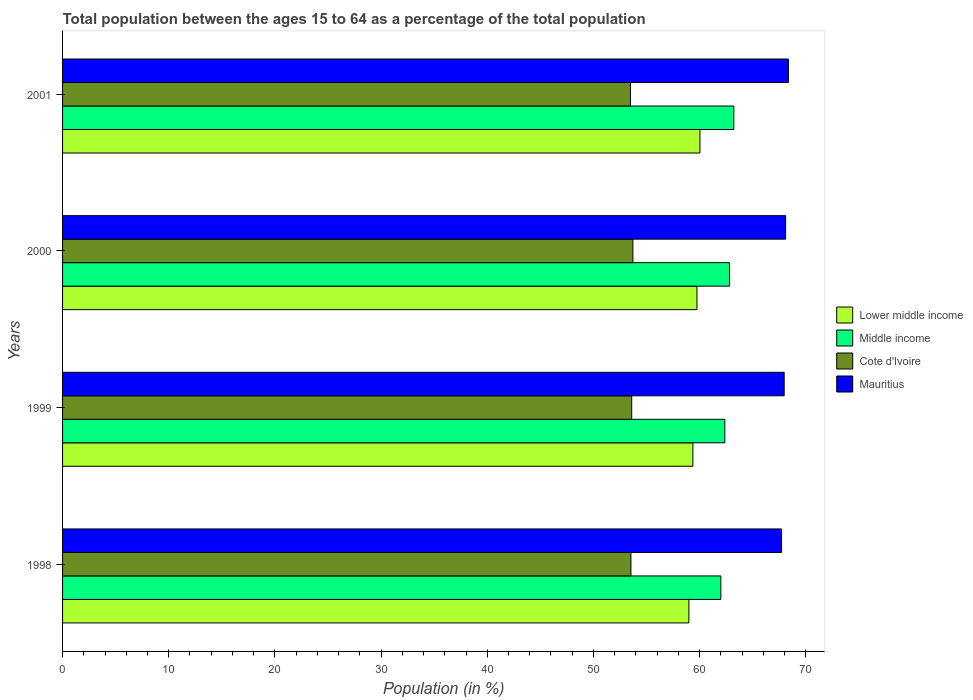Are the number of bars per tick equal to the number of legend labels?
Offer a terse response. Yes. Are the number of bars on each tick of the Y-axis equal?
Make the answer very short. Yes. How many bars are there on the 4th tick from the bottom?
Offer a very short reply. 4. What is the label of the 1st group of bars from the top?
Offer a terse response. 2001. In how many cases, is the number of bars for a given year not equal to the number of legend labels?
Ensure brevity in your answer.  0. What is the percentage of the population ages 15 to 64 in Lower middle income in 2001?
Your answer should be compact. 60.04. Across all years, what is the maximum percentage of the population ages 15 to 64 in Middle income?
Provide a succinct answer. 63.23. Across all years, what is the minimum percentage of the population ages 15 to 64 in Mauritius?
Give a very brief answer. 67.72. In which year was the percentage of the population ages 15 to 64 in Lower middle income maximum?
Your answer should be very brief. 2001. In which year was the percentage of the population ages 15 to 64 in Lower middle income minimum?
Ensure brevity in your answer.  1998. What is the total percentage of the population ages 15 to 64 in Mauritius in the graph?
Provide a short and direct response. 272.15. What is the difference between the percentage of the population ages 15 to 64 in Lower middle income in 1998 and that in 2000?
Give a very brief answer. -0.76. What is the difference between the percentage of the population ages 15 to 64 in Lower middle income in 2000 and the percentage of the population ages 15 to 64 in Cote d'Ivoire in 1999?
Offer a terse response. 6.15. What is the average percentage of the population ages 15 to 64 in Mauritius per year?
Make the answer very short. 68.04. In the year 2000, what is the difference between the percentage of the population ages 15 to 64 in Cote d'Ivoire and percentage of the population ages 15 to 64 in Lower middle income?
Your answer should be very brief. -6.03. What is the ratio of the percentage of the population ages 15 to 64 in Cote d'Ivoire in 1998 to that in 2000?
Your answer should be compact. 1. Is the percentage of the population ages 15 to 64 in Middle income in 2000 less than that in 2001?
Your response must be concise. Yes. Is the difference between the percentage of the population ages 15 to 64 in Cote d'Ivoire in 1999 and 2001 greater than the difference between the percentage of the population ages 15 to 64 in Lower middle income in 1999 and 2001?
Provide a short and direct response. Yes. What is the difference between the highest and the second highest percentage of the population ages 15 to 64 in Cote d'Ivoire?
Offer a terse response. 0.11. What is the difference between the highest and the lowest percentage of the population ages 15 to 64 in Lower middle income?
Offer a very short reply. 1.04. In how many years, is the percentage of the population ages 15 to 64 in Mauritius greater than the average percentage of the population ages 15 to 64 in Mauritius taken over all years?
Give a very brief answer. 2. Is the sum of the percentage of the population ages 15 to 64 in Mauritius in 1998 and 2001 greater than the maximum percentage of the population ages 15 to 64 in Middle income across all years?
Give a very brief answer. Yes. Is it the case that in every year, the sum of the percentage of the population ages 15 to 64 in Middle income and percentage of the population ages 15 to 64 in Mauritius is greater than the sum of percentage of the population ages 15 to 64 in Cote d'Ivoire and percentage of the population ages 15 to 64 in Lower middle income?
Offer a very short reply. Yes. What does the 4th bar from the top in 2000 represents?
Ensure brevity in your answer.  Lower middle income. What does the 3rd bar from the bottom in 1998 represents?
Ensure brevity in your answer.  Cote d'Ivoire. How many bars are there?
Give a very brief answer. 16. Are the values on the major ticks of X-axis written in scientific E-notation?
Your answer should be very brief. No. How many legend labels are there?
Provide a short and direct response. 4. What is the title of the graph?
Offer a very short reply. Total population between the ages 15 to 64 as a percentage of the total population. What is the label or title of the Y-axis?
Your response must be concise. Years. What is the Population (in %) in Lower middle income in 1998?
Make the answer very short. 58.99. What is the Population (in %) of Middle income in 1998?
Make the answer very short. 62. What is the Population (in %) in Cote d'Ivoire in 1998?
Offer a very short reply. 53.53. What is the Population (in %) of Mauritius in 1998?
Your answer should be very brief. 67.72. What is the Population (in %) in Lower middle income in 1999?
Your answer should be very brief. 59.37. What is the Population (in %) of Middle income in 1999?
Provide a short and direct response. 62.38. What is the Population (in %) of Cote d'Ivoire in 1999?
Ensure brevity in your answer.  53.61. What is the Population (in %) in Mauritius in 1999?
Your response must be concise. 67.97. What is the Population (in %) in Lower middle income in 2000?
Provide a short and direct response. 59.75. What is the Population (in %) in Middle income in 2000?
Make the answer very short. 62.82. What is the Population (in %) in Cote d'Ivoire in 2000?
Make the answer very short. 53.72. What is the Population (in %) of Mauritius in 2000?
Keep it short and to the point. 68.1. What is the Population (in %) of Lower middle income in 2001?
Your answer should be compact. 60.04. What is the Population (in %) of Middle income in 2001?
Make the answer very short. 63.23. What is the Population (in %) in Cote d'Ivoire in 2001?
Offer a very short reply. 53.49. What is the Population (in %) in Mauritius in 2001?
Provide a succinct answer. 68.37. Across all years, what is the maximum Population (in %) in Lower middle income?
Provide a succinct answer. 60.04. Across all years, what is the maximum Population (in %) in Middle income?
Ensure brevity in your answer.  63.23. Across all years, what is the maximum Population (in %) of Cote d'Ivoire?
Make the answer very short. 53.72. Across all years, what is the maximum Population (in %) of Mauritius?
Your response must be concise. 68.37. Across all years, what is the minimum Population (in %) of Lower middle income?
Ensure brevity in your answer.  58.99. Across all years, what is the minimum Population (in %) of Middle income?
Offer a terse response. 62. Across all years, what is the minimum Population (in %) of Cote d'Ivoire?
Provide a succinct answer. 53.49. Across all years, what is the minimum Population (in %) in Mauritius?
Keep it short and to the point. 67.72. What is the total Population (in %) in Lower middle income in the graph?
Ensure brevity in your answer.  238.15. What is the total Population (in %) of Middle income in the graph?
Ensure brevity in your answer.  250.43. What is the total Population (in %) of Cote d'Ivoire in the graph?
Your answer should be compact. 214.35. What is the total Population (in %) in Mauritius in the graph?
Keep it short and to the point. 272.15. What is the difference between the Population (in %) of Lower middle income in 1998 and that in 1999?
Your answer should be compact. -0.38. What is the difference between the Population (in %) in Middle income in 1998 and that in 1999?
Give a very brief answer. -0.38. What is the difference between the Population (in %) of Cote d'Ivoire in 1998 and that in 1999?
Give a very brief answer. -0.07. What is the difference between the Population (in %) of Mauritius in 1998 and that in 1999?
Your answer should be very brief. -0.25. What is the difference between the Population (in %) in Lower middle income in 1998 and that in 2000?
Your answer should be very brief. -0.76. What is the difference between the Population (in %) of Middle income in 1998 and that in 2000?
Provide a short and direct response. -0.82. What is the difference between the Population (in %) of Cote d'Ivoire in 1998 and that in 2000?
Provide a succinct answer. -0.18. What is the difference between the Population (in %) of Mauritius in 1998 and that in 2000?
Offer a very short reply. -0.38. What is the difference between the Population (in %) of Lower middle income in 1998 and that in 2001?
Make the answer very short. -1.04. What is the difference between the Population (in %) of Middle income in 1998 and that in 2001?
Your answer should be compact. -1.22. What is the difference between the Population (in %) of Cote d'Ivoire in 1998 and that in 2001?
Your answer should be compact. 0.05. What is the difference between the Population (in %) of Mauritius in 1998 and that in 2001?
Your answer should be compact. -0.65. What is the difference between the Population (in %) of Lower middle income in 1999 and that in 2000?
Keep it short and to the point. -0.38. What is the difference between the Population (in %) of Middle income in 1999 and that in 2000?
Make the answer very short. -0.44. What is the difference between the Population (in %) of Cote d'Ivoire in 1999 and that in 2000?
Give a very brief answer. -0.11. What is the difference between the Population (in %) of Mauritius in 1999 and that in 2000?
Your answer should be compact. -0.14. What is the difference between the Population (in %) in Lower middle income in 1999 and that in 2001?
Provide a short and direct response. -0.67. What is the difference between the Population (in %) of Middle income in 1999 and that in 2001?
Ensure brevity in your answer.  -0.85. What is the difference between the Population (in %) in Cote d'Ivoire in 1999 and that in 2001?
Your answer should be very brief. 0.12. What is the difference between the Population (in %) of Mauritius in 1999 and that in 2001?
Make the answer very short. -0.4. What is the difference between the Population (in %) in Lower middle income in 2000 and that in 2001?
Your response must be concise. -0.28. What is the difference between the Population (in %) in Middle income in 2000 and that in 2001?
Offer a very short reply. -0.4. What is the difference between the Population (in %) in Cote d'Ivoire in 2000 and that in 2001?
Ensure brevity in your answer.  0.23. What is the difference between the Population (in %) in Mauritius in 2000 and that in 2001?
Give a very brief answer. -0.26. What is the difference between the Population (in %) in Lower middle income in 1998 and the Population (in %) in Middle income in 1999?
Give a very brief answer. -3.39. What is the difference between the Population (in %) of Lower middle income in 1998 and the Population (in %) of Cote d'Ivoire in 1999?
Offer a terse response. 5.38. What is the difference between the Population (in %) of Lower middle income in 1998 and the Population (in %) of Mauritius in 1999?
Your answer should be compact. -8.98. What is the difference between the Population (in %) of Middle income in 1998 and the Population (in %) of Cote d'Ivoire in 1999?
Your answer should be compact. 8.4. What is the difference between the Population (in %) in Middle income in 1998 and the Population (in %) in Mauritius in 1999?
Keep it short and to the point. -5.96. What is the difference between the Population (in %) in Cote d'Ivoire in 1998 and the Population (in %) in Mauritius in 1999?
Make the answer very short. -14.43. What is the difference between the Population (in %) of Lower middle income in 1998 and the Population (in %) of Middle income in 2000?
Your response must be concise. -3.83. What is the difference between the Population (in %) of Lower middle income in 1998 and the Population (in %) of Cote d'Ivoire in 2000?
Your answer should be very brief. 5.27. What is the difference between the Population (in %) in Lower middle income in 1998 and the Population (in %) in Mauritius in 2000?
Your answer should be compact. -9.11. What is the difference between the Population (in %) of Middle income in 1998 and the Population (in %) of Cote d'Ivoire in 2000?
Your response must be concise. 8.28. What is the difference between the Population (in %) in Middle income in 1998 and the Population (in %) in Mauritius in 2000?
Make the answer very short. -6.1. What is the difference between the Population (in %) of Cote d'Ivoire in 1998 and the Population (in %) of Mauritius in 2000?
Your answer should be very brief. -14.57. What is the difference between the Population (in %) of Lower middle income in 1998 and the Population (in %) of Middle income in 2001?
Offer a very short reply. -4.23. What is the difference between the Population (in %) in Lower middle income in 1998 and the Population (in %) in Cote d'Ivoire in 2001?
Your answer should be compact. 5.5. What is the difference between the Population (in %) of Lower middle income in 1998 and the Population (in %) of Mauritius in 2001?
Your answer should be very brief. -9.37. What is the difference between the Population (in %) in Middle income in 1998 and the Population (in %) in Cote d'Ivoire in 2001?
Offer a terse response. 8.51. What is the difference between the Population (in %) in Middle income in 1998 and the Population (in %) in Mauritius in 2001?
Keep it short and to the point. -6.36. What is the difference between the Population (in %) of Cote d'Ivoire in 1998 and the Population (in %) of Mauritius in 2001?
Offer a terse response. -14.83. What is the difference between the Population (in %) in Lower middle income in 1999 and the Population (in %) in Middle income in 2000?
Your answer should be compact. -3.45. What is the difference between the Population (in %) of Lower middle income in 1999 and the Population (in %) of Cote d'Ivoire in 2000?
Offer a terse response. 5.65. What is the difference between the Population (in %) of Lower middle income in 1999 and the Population (in %) of Mauritius in 2000?
Offer a very short reply. -8.73. What is the difference between the Population (in %) of Middle income in 1999 and the Population (in %) of Cote d'Ivoire in 2000?
Offer a very short reply. 8.66. What is the difference between the Population (in %) in Middle income in 1999 and the Population (in %) in Mauritius in 2000?
Provide a short and direct response. -5.72. What is the difference between the Population (in %) in Cote d'Ivoire in 1999 and the Population (in %) in Mauritius in 2000?
Keep it short and to the point. -14.5. What is the difference between the Population (in %) of Lower middle income in 1999 and the Population (in %) of Middle income in 2001?
Your answer should be compact. -3.86. What is the difference between the Population (in %) in Lower middle income in 1999 and the Population (in %) in Cote d'Ivoire in 2001?
Your answer should be very brief. 5.88. What is the difference between the Population (in %) in Lower middle income in 1999 and the Population (in %) in Mauritius in 2001?
Make the answer very short. -9. What is the difference between the Population (in %) of Middle income in 1999 and the Population (in %) of Cote d'Ivoire in 2001?
Offer a terse response. 8.89. What is the difference between the Population (in %) of Middle income in 1999 and the Population (in %) of Mauritius in 2001?
Your answer should be very brief. -5.99. What is the difference between the Population (in %) of Cote d'Ivoire in 1999 and the Population (in %) of Mauritius in 2001?
Give a very brief answer. -14.76. What is the difference between the Population (in %) of Lower middle income in 2000 and the Population (in %) of Middle income in 2001?
Ensure brevity in your answer.  -3.47. What is the difference between the Population (in %) in Lower middle income in 2000 and the Population (in %) in Cote d'Ivoire in 2001?
Provide a succinct answer. 6.27. What is the difference between the Population (in %) of Lower middle income in 2000 and the Population (in %) of Mauritius in 2001?
Ensure brevity in your answer.  -8.61. What is the difference between the Population (in %) in Middle income in 2000 and the Population (in %) in Cote d'Ivoire in 2001?
Make the answer very short. 9.34. What is the difference between the Population (in %) in Middle income in 2000 and the Population (in %) in Mauritius in 2001?
Offer a very short reply. -5.54. What is the difference between the Population (in %) in Cote d'Ivoire in 2000 and the Population (in %) in Mauritius in 2001?
Offer a very short reply. -14.65. What is the average Population (in %) of Lower middle income per year?
Keep it short and to the point. 59.54. What is the average Population (in %) of Middle income per year?
Your response must be concise. 62.61. What is the average Population (in %) in Cote d'Ivoire per year?
Offer a terse response. 53.59. What is the average Population (in %) in Mauritius per year?
Provide a succinct answer. 68.04. In the year 1998, what is the difference between the Population (in %) of Lower middle income and Population (in %) of Middle income?
Provide a succinct answer. -3.01. In the year 1998, what is the difference between the Population (in %) of Lower middle income and Population (in %) of Cote d'Ivoire?
Your answer should be compact. 5.46. In the year 1998, what is the difference between the Population (in %) of Lower middle income and Population (in %) of Mauritius?
Your response must be concise. -8.73. In the year 1998, what is the difference between the Population (in %) of Middle income and Population (in %) of Cote d'Ivoire?
Give a very brief answer. 8.47. In the year 1998, what is the difference between the Population (in %) of Middle income and Population (in %) of Mauritius?
Provide a succinct answer. -5.72. In the year 1998, what is the difference between the Population (in %) of Cote d'Ivoire and Population (in %) of Mauritius?
Ensure brevity in your answer.  -14.18. In the year 1999, what is the difference between the Population (in %) in Lower middle income and Population (in %) in Middle income?
Give a very brief answer. -3.01. In the year 1999, what is the difference between the Population (in %) in Lower middle income and Population (in %) in Cote d'Ivoire?
Keep it short and to the point. 5.76. In the year 1999, what is the difference between the Population (in %) in Lower middle income and Population (in %) in Mauritius?
Ensure brevity in your answer.  -8.6. In the year 1999, what is the difference between the Population (in %) in Middle income and Population (in %) in Cote d'Ivoire?
Give a very brief answer. 8.77. In the year 1999, what is the difference between the Population (in %) of Middle income and Population (in %) of Mauritius?
Ensure brevity in your answer.  -5.59. In the year 1999, what is the difference between the Population (in %) in Cote d'Ivoire and Population (in %) in Mauritius?
Offer a terse response. -14.36. In the year 2000, what is the difference between the Population (in %) in Lower middle income and Population (in %) in Middle income?
Ensure brevity in your answer.  -3.07. In the year 2000, what is the difference between the Population (in %) in Lower middle income and Population (in %) in Cote d'Ivoire?
Keep it short and to the point. 6.03. In the year 2000, what is the difference between the Population (in %) of Lower middle income and Population (in %) of Mauritius?
Make the answer very short. -8.35. In the year 2000, what is the difference between the Population (in %) of Middle income and Population (in %) of Cote d'Ivoire?
Your answer should be compact. 9.1. In the year 2000, what is the difference between the Population (in %) in Middle income and Population (in %) in Mauritius?
Your answer should be compact. -5.28. In the year 2000, what is the difference between the Population (in %) of Cote d'Ivoire and Population (in %) of Mauritius?
Make the answer very short. -14.38. In the year 2001, what is the difference between the Population (in %) of Lower middle income and Population (in %) of Middle income?
Ensure brevity in your answer.  -3.19. In the year 2001, what is the difference between the Population (in %) of Lower middle income and Population (in %) of Cote d'Ivoire?
Ensure brevity in your answer.  6.55. In the year 2001, what is the difference between the Population (in %) of Lower middle income and Population (in %) of Mauritius?
Your answer should be compact. -8.33. In the year 2001, what is the difference between the Population (in %) in Middle income and Population (in %) in Cote d'Ivoire?
Make the answer very short. 9.74. In the year 2001, what is the difference between the Population (in %) of Middle income and Population (in %) of Mauritius?
Your answer should be compact. -5.14. In the year 2001, what is the difference between the Population (in %) of Cote d'Ivoire and Population (in %) of Mauritius?
Provide a short and direct response. -14.88. What is the ratio of the Population (in %) of Lower middle income in 1998 to that in 2000?
Make the answer very short. 0.99. What is the ratio of the Population (in %) of Middle income in 1998 to that in 2000?
Offer a terse response. 0.99. What is the ratio of the Population (in %) of Mauritius in 1998 to that in 2000?
Provide a short and direct response. 0.99. What is the ratio of the Population (in %) in Lower middle income in 1998 to that in 2001?
Offer a very short reply. 0.98. What is the ratio of the Population (in %) of Middle income in 1998 to that in 2001?
Give a very brief answer. 0.98. What is the ratio of the Population (in %) in Cote d'Ivoire in 1998 to that in 2001?
Your answer should be very brief. 1. What is the ratio of the Population (in %) of Lower middle income in 1999 to that in 2000?
Ensure brevity in your answer.  0.99. What is the ratio of the Population (in %) of Middle income in 1999 to that in 2000?
Your answer should be compact. 0.99. What is the ratio of the Population (in %) of Lower middle income in 1999 to that in 2001?
Your answer should be very brief. 0.99. What is the ratio of the Population (in %) of Middle income in 1999 to that in 2001?
Make the answer very short. 0.99. What is the ratio of the Population (in %) in Cote d'Ivoire in 1999 to that in 2001?
Give a very brief answer. 1. What is the ratio of the Population (in %) in Mauritius in 1999 to that in 2001?
Give a very brief answer. 0.99. What is the ratio of the Population (in %) in Middle income in 2000 to that in 2001?
Offer a terse response. 0.99. What is the difference between the highest and the second highest Population (in %) in Lower middle income?
Your answer should be very brief. 0.28. What is the difference between the highest and the second highest Population (in %) of Middle income?
Ensure brevity in your answer.  0.4. What is the difference between the highest and the second highest Population (in %) of Cote d'Ivoire?
Provide a succinct answer. 0.11. What is the difference between the highest and the second highest Population (in %) in Mauritius?
Provide a succinct answer. 0.26. What is the difference between the highest and the lowest Population (in %) in Lower middle income?
Provide a short and direct response. 1.04. What is the difference between the highest and the lowest Population (in %) in Middle income?
Offer a terse response. 1.22. What is the difference between the highest and the lowest Population (in %) in Cote d'Ivoire?
Provide a short and direct response. 0.23. What is the difference between the highest and the lowest Population (in %) of Mauritius?
Keep it short and to the point. 0.65. 